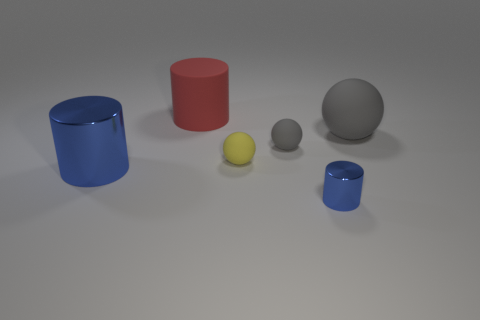How many gray balls must be subtracted to get 1 gray balls? 1 Add 3 small gray rubber spheres. How many objects exist? 9 Add 6 blue shiny objects. How many blue shiny objects are left? 8 Add 5 large blue shiny objects. How many large blue shiny objects exist? 6 Subtract 0 purple cylinders. How many objects are left? 6 Subtract all spheres. Subtract all brown blocks. How many objects are left? 3 